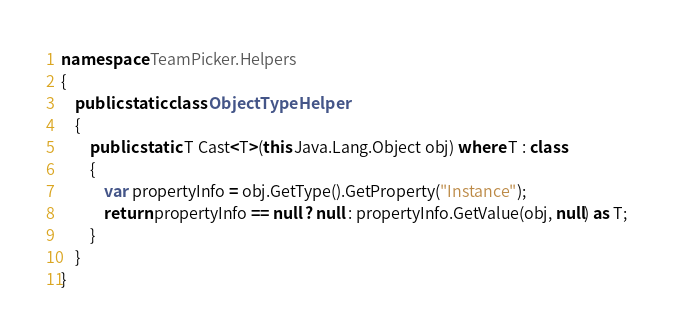<code> <loc_0><loc_0><loc_500><loc_500><_C#_>namespace TeamPicker.Helpers
{
    public static class ObjectTypeHelper
    {
        public static T Cast<T>(this Java.Lang.Object obj) where T : class
        {
            var propertyInfo = obj.GetType().GetProperty("Instance");
            return propertyInfo == null ? null : propertyInfo.GetValue(obj, null) as T;
        }
    }
}</code> 